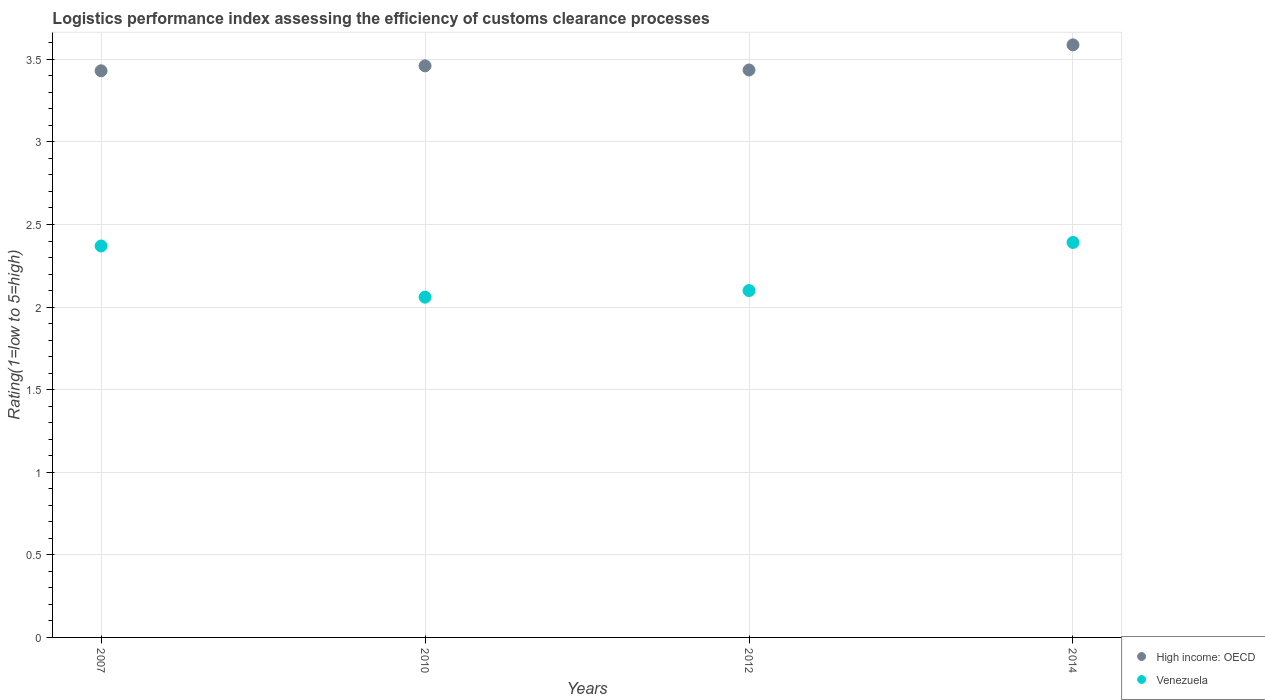What is the Logistic performance index in High income: OECD in 2014?
Your response must be concise. 3.59. Across all years, what is the maximum Logistic performance index in High income: OECD?
Give a very brief answer. 3.59. Across all years, what is the minimum Logistic performance index in Venezuela?
Ensure brevity in your answer.  2.06. In which year was the Logistic performance index in Venezuela maximum?
Give a very brief answer. 2014. What is the total Logistic performance index in Venezuela in the graph?
Keep it short and to the point. 8.92. What is the difference between the Logistic performance index in High income: OECD in 2007 and that in 2014?
Offer a very short reply. -0.16. What is the difference between the Logistic performance index in High income: OECD in 2010 and the Logistic performance index in Venezuela in 2012?
Provide a short and direct response. 1.36. What is the average Logistic performance index in Venezuela per year?
Provide a succinct answer. 2.23. In the year 2007, what is the difference between the Logistic performance index in High income: OECD and Logistic performance index in Venezuela?
Your response must be concise. 1.06. In how many years, is the Logistic performance index in High income: OECD greater than 3.5?
Offer a terse response. 1. What is the ratio of the Logistic performance index in Venezuela in 2012 to that in 2014?
Keep it short and to the point. 0.88. Is the Logistic performance index in Venezuela in 2010 less than that in 2014?
Your answer should be very brief. Yes. Is the difference between the Logistic performance index in High income: OECD in 2010 and 2012 greater than the difference between the Logistic performance index in Venezuela in 2010 and 2012?
Keep it short and to the point. Yes. What is the difference between the highest and the second highest Logistic performance index in Venezuela?
Give a very brief answer. 0.02. What is the difference between the highest and the lowest Logistic performance index in Venezuela?
Offer a terse response. 0.33. Is the Logistic performance index in Venezuela strictly greater than the Logistic performance index in High income: OECD over the years?
Ensure brevity in your answer.  No. Is the Logistic performance index in High income: OECD strictly less than the Logistic performance index in Venezuela over the years?
Give a very brief answer. No. How many dotlines are there?
Your response must be concise. 2. How many legend labels are there?
Keep it short and to the point. 2. What is the title of the graph?
Your answer should be compact. Logistics performance index assessing the efficiency of customs clearance processes. What is the label or title of the Y-axis?
Your answer should be very brief. Rating(1=low to 5=high). What is the Rating(1=low to 5=high) in High income: OECD in 2007?
Provide a short and direct response. 3.43. What is the Rating(1=low to 5=high) of Venezuela in 2007?
Ensure brevity in your answer.  2.37. What is the Rating(1=low to 5=high) of High income: OECD in 2010?
Your answer should be compact. 3.46. What is the Rating(1=low to 5=high) of Venezuela in 2010?
Provide a succinct answer. 2.06. What is the Rating(1=low to 5=high) in High income: OECD in 2012?
Offer a very short reply. 3.44. What is the Rating(1=low to 5=high) in Venezuela in 2012?
Make the answer very short. 2.1. What is the Rating(1=low to 5=high) in High income: OECD in 2014?
Offer a very short reply. 3.59. What is the Rating(1=low to 5=high) of Venezuela in 2014?
Give a very brief answer. 2.39. Across all years, what is the maximum Rating(1=low to 5=high) in High income: OECD?
Make the answer very short. 3.59. Across all years, what is the maximum Rating(1=low to 5=high) of Venezuela?
Ensure brevity in your answer.  2.39. Across all years, what is the minimum Rating(1=low to 5=high) in High income: OECD?
Your answer should be compact. 3.43. Across all years, what is the minimum Rating(1=low to 5=high) in Venezuela?
Make the answer very short. 2.06. What is the total Rating(1=low to 5=high) of High income: OECD in the graph?
Keep it short and to the point. 13.91. What is the total Rating(1=low to 5=high) of Venezuela in the graph?
Offer a very short reply. 8.92. What is the difference between the Rating(1=low to 5=high) in High income: OECD in 2007 and that in 2010?
Provide a succinct answer. -0.03. What is the difference between the Rating(1=low to 5=high) of Venezuela in 2007 and that in 2010?
Ensure brevity in your answer.  0.31. What is the difference between the Rating(1=low to 5=high) in High income: OECD in 2007 and that in 2012?
Provide a short and direct response. -0. What is the difference between the Rating(1=low to 5=high) in Venezuela in 2007 and that in 2012?
Your answer should be compact. 0.27. What is the difference between the Rating(1=low to 5=high) in High income: OECD in 2007 and that in 2014?
Ensure brevity in your answer.  -0.16. What is the difference between the Rating(1=low to 5=high) in Venezuela in 2007 and that in 2014?
Offer a very short reply. -0.02. What is the difference between the Rating(1=low to 5=high) in High income: OECD in 2010 and that in 2012?
Your answer should be compact. 0.03. What is the difference between the Rating(1=low to 5=high) of Venezuela in 2010 and that in 2012?
Your response must be concise. -0.04. What is the difference between the Rating(1=low to 5=high) of High income: OECD in 2010 and that in 2014?
Offer a terse response. -0.13. What is the difference between the Rating(1=low to 5=high) in Venezuela in 2010 and that in 2014?
Give a very brief answer. -0.33. What is the difference between the Rating(1=low to 5=high) in High income: OECD in 2012 and that in 2014?
Make the answer very short. -0.15. What is the difference between the Rating(1=low to 5=high) of Venezuela in 2012 and that in 2014?
Your response must be concise. -0.29. What is the difference between the Rating(1=low to 5=high) in High income: OECD in 2007 and the Rating(1=low to 5=high) in Venezuela in 2010?
Your answer should be compact. 1.37. What is the difference between the Rating(1=low to 5=high) of High income: OECD in 2007 and the Rating(1=low to 5=high) of Venezuela in 2012?
Keep it short and to the point. 1.33. What is the difference between the Rating(1=low to 5=high) in High income: OECD in 2007 and the Rating(1=low to 5=high) in Venezuela in 2014?
Give a very brief answer. 1.04. What is the difference between the Rating(1=low to 5=high) of High income: OECD in 2010 and the Rating(1=low to 5=high) of Venezuela in 2012?
Provide a succinct answer. 1.36. What is the difference between the Rating(1=low to 5=high) in High income: OECD in 2010 and the Rating(1=low to 5=high) in Venezuela in 2014?
Your answer should be very brief. 1.07. What is the difference between the Rating(1=low to 5=high) of High income: OECD in 2012 and the Rating(1=low to 5=high) of Venezuela in 2014?
Ensure brevity in your answer.  1.04. What is the average Rating(1=low to 5=high) in High income: OECD per year?
Make the answer very short. 3.48. What is the average Rating(1=low to 5=high) in Venezuela per year?
Your answer should be very brief. 2.23. In the year 2007, what is the difference between the Rating(1=low to 5=high) in High income: OECD and Rating(1=low to 5=high) in Venezuela?
Ensure brevity in your answer.  1.06. In the year 2010, what is the difference between the Rating(1=low to 5=high) of High income: OECD and Rating(1=low to 5=high) of Venezuela?
Keep it short and to the point. 1.4. In the year 2012, what is the difference between the Rating(1=low to 5=high) in High income: OECD and Rating(1=low to 5=high) in Venezuela?
Offer a terse response. 1.34. In the year 2014, what is the difference between the Rating(1=low to 5=high) in High income: OECD and Rating(1=low to 5=high) in Venezuela?
Provide a short and direct response. 1.2. What is the ratio of the Rating(1=low to 5=high) of Venezuela in 2007 to that in 2010?
Provide a succinct answer. 1.15. What is the ratio of the Rating(1=low to 5=high) in High income: OECD in 2007 to that in 2012?
Ensure brevity in your answer.  1. What is the ratio of the Rating(1=low to 5=high) in Venezuela in 2007 to that in 2012?
Offer a very short reply. 1.13. What is the ratio of the Rating(1=low to 5=high) of High income: OECD in 2007 to that in 2014?
Keep it short and to the point. 0.96. What is the ratio of the Rating(1=low to 5=high) in Venezuela in 2007 to that in 2014?
Your answer should be very brief. 0.99. What is the ratio of the Rating(1=low to 5=high) in High income: OECD in 2010 to that in 2012?
Offer a very short reply. 1.01. What is the ratio of the Rating(1=low to 5=high) of Venezuela in 2010 to that in 2012?
Your answer should be very brief. 0.98. What is the ratio of the Rating(1=low to 5=high) in High income: OECD in 2010 to that in 2014?
Make the answer very short. 0.96. What is the ratio of the Rating(1=low to 5=high) of Venezuela in 2010 to that in 2014?
Ensure brevity in your answer.  0.86. What is the ratio of the Rating(1=low to 5=high) of High income: OECD in 2012 to that in 2014?
Ensure brevity in your answer.  0.96. What is the ratio of the Rating(1=low to 5=high) of Venezuela in 2012 to that in 2014?
Your answer should be compact. 0.88. What is the difference between the highest and the second highest Rating(1=low to 5=high) in High income: OECD?
Make the answer very short. 0.13. What is the difference between the highest and the second highest Rating(1=low to 5=high) of Venezuela?
Your response must be concise. 0.02. What is the difference between the highest and the lowest Rating(1=low to 5=high) of High income: OECD?
Keep it short and to the point. 0.16. What is the difference between the highest and the lowest Rating(1=low to 5=high) of Venezuela?
Provide a succinct answer. 0.33. 